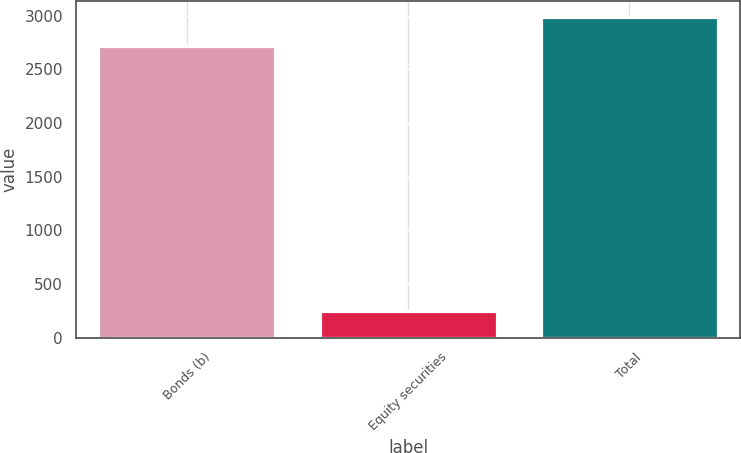Convert chart. <chart><loc_0><loc_0><loc_500><loc_500><bar_chart><fcel>Bonds (b)<fcel>Equity securities<fcel>Total<nl><fcel>2715<fcel>246<fcel>2986.5<nl></chart> 